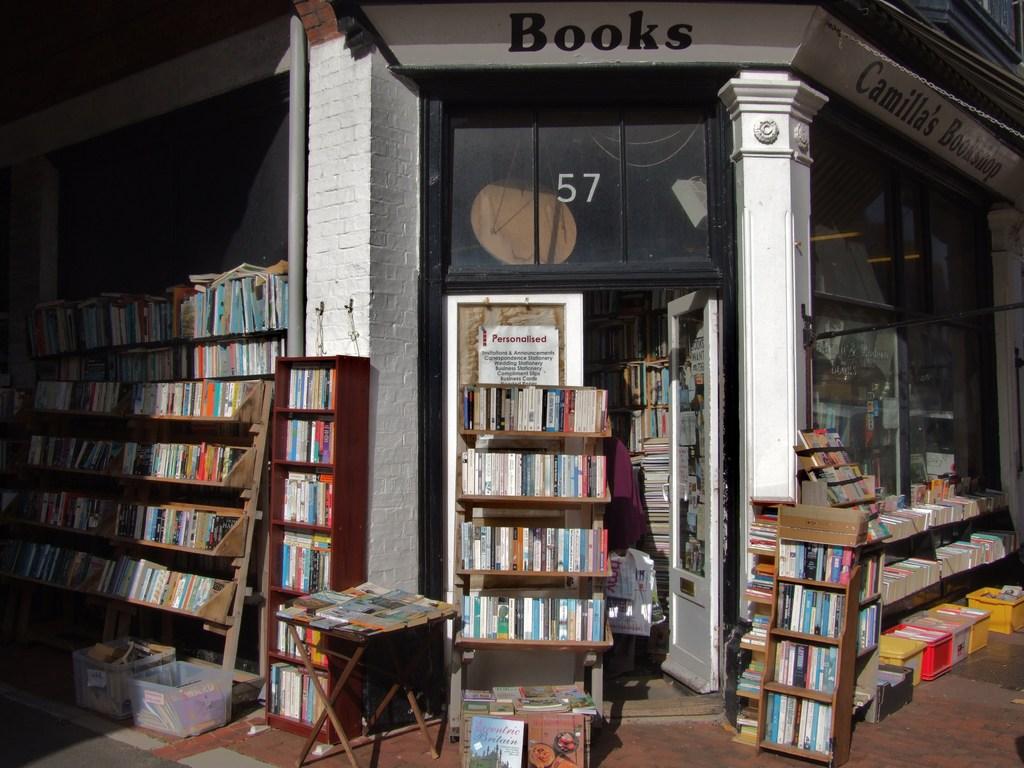What address number is this store?
Ensure brevity in your answer.  57. Is the name on the side at the top camilla's bookshop?
Offer a terse response. Yes. 